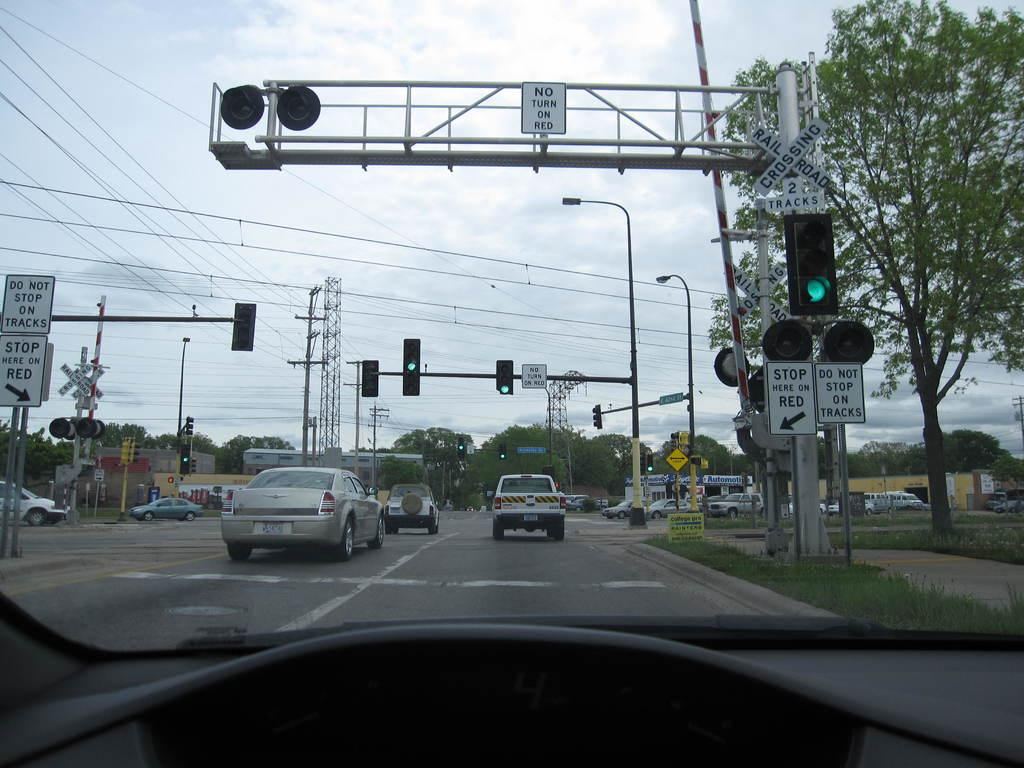<image>
Describe the image concisely. A white sign tells drivers not to stop on the tracks. 